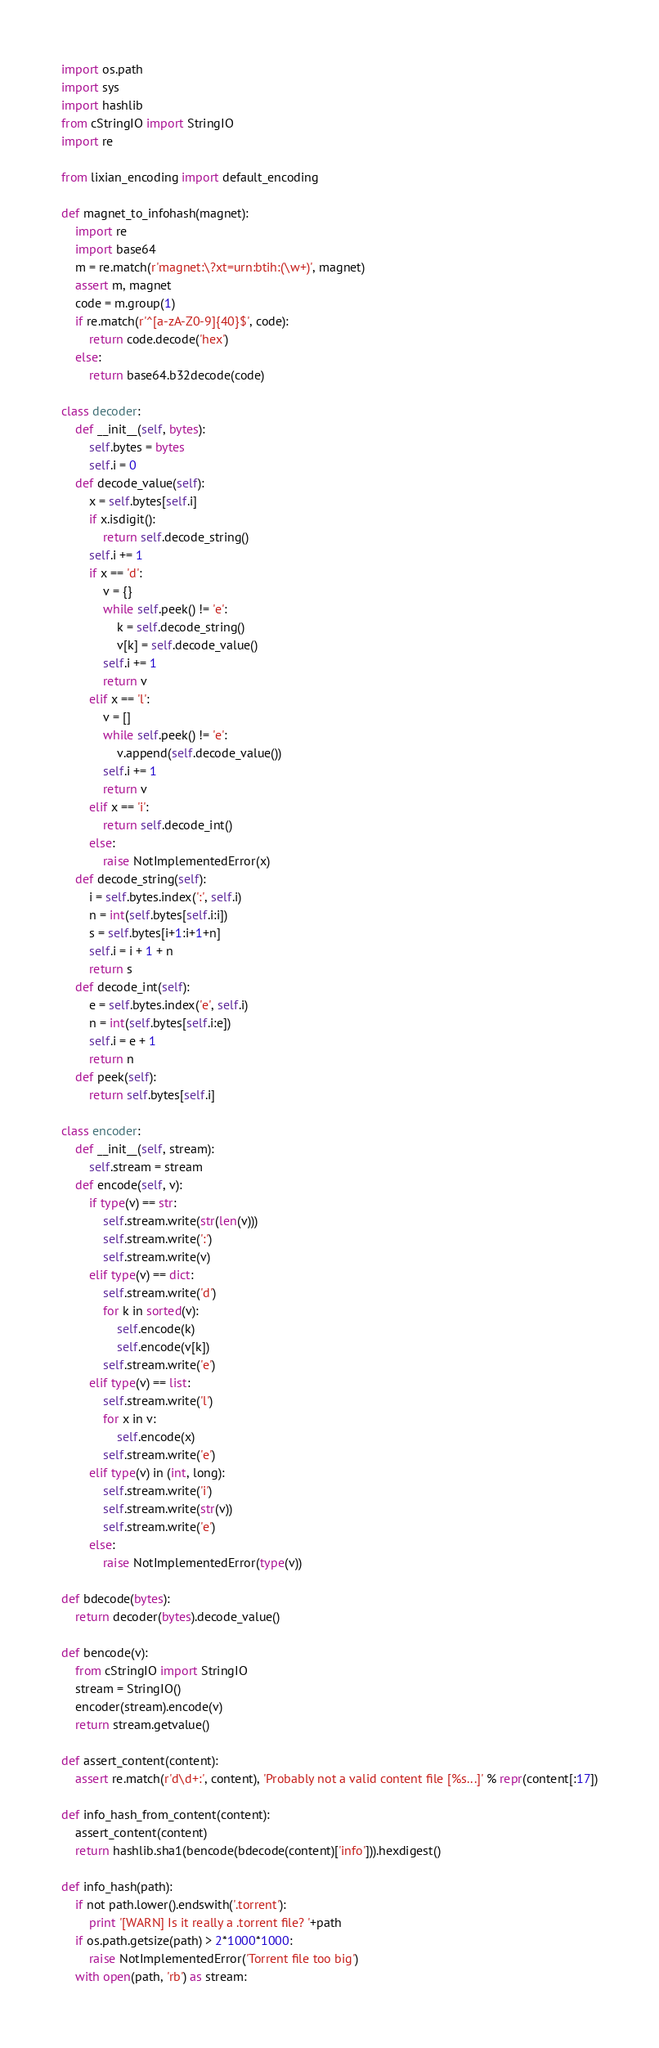<code> <loc_0><loc_0><loc_500><loc_500><_Python_>
import os.path
import sys
import hashlib
from cStringIO import StringIO
import re

from lixian_encoding import default_encoding

def magnet_to_infohash(magnet):
	import re
	import base64
	m = re.match(r'magnet:\?xt=urn:btih:(\w+)', magnet)
	assert m, magnet
	code = m.group(1)
	if re.match(r'^[a-zA-Z0-9]{40}$', code):
		return code.decode('hex')
	else:
		return base64.b32decode(code)

class decoder:
	def __init__(self, bytes):
		self.bytes = bytes
		self.i = 0
	def decode_value(self):
		x = self.bytes[self.i]
		if x.isdigit():
			return self.decode_string()
		self.i += 1
		if x == 'd':
			v = {}
			while self.peek() != 'e':
				k = self.decode_string()
				v[k] = self.decode_value()
			self.i += 1
			return v
		elif x == 'l':
			v = []
			while self.peek() != 'e':
				v.append(self.decode_value())
			self.i += 1
			return v
		elif x == 'i':
			return self.decode_int()
		else:
			raise NotImplementedError(x)
	def decode_string(self):
		i = self.bytes.index(':', self.i)
		n = int(self.bytes[self.i:i])
		s = self.bytes[i+1:i+1+n]
		self.i = i + 1 + n
		return s
	def decode_int(self):
		e = self.bytes.index('e', self.i)
		n = int(self.bytes[self.i:e])
		self.i = e + 1
		return n
	def peek(self):
		return self.bytes[self.i]

class encoder:
	def __init__(self, stream):
		self.stream = stream
	def encode(self, v):
		if type(v) == str:
			self.stream.write(str(len(v)))
			self.stream.write(':')
			self.stream.write(v)
		elif type(v) == dict:
			self.stream.write('d')
			for k in sorted(v):
				self.encode(k)
				self.encode(v[k])
			self.stream.write('e')
		elif type(v) == list:
			self.stream.write('l')
			for x in v:
				self.encode(x)
			self.stream.write('e')
		elif type(v) in (int, long):
			self.stream.write('i')
			self.stream.write(str(v))
			self.stream.write('e')
		else:
			raise NotImplementedError(type(v))

def bdecode(bytes):
	return decoder(bytes).decode_value()

def bencode(v):
	from cStringIO import StringIO
	stream = StringIO()
	encoder(stream).encode(v)
	return stream.getvalue()

def assert_content(content):
	assert re.match(r'd\d+:', content), 'Probably not a valid content file [%s...]' % repr(content[:17])

def info_hash_from_content(content):
	assert_content(content)
	return hashlib.sha1(bencode(bdecode(content)['info'])).hexdigest()

def info_hash(path):
	if not path.lower().endswith('.torrent'):
		print '[WARN] Is it really a .torrent file? '+path
	if os.path.getsize(path) > 2*1000*1000:
		raise NotImplementedError('Torrent file too big')
	with open(path, 'rb') as stream:</code> 